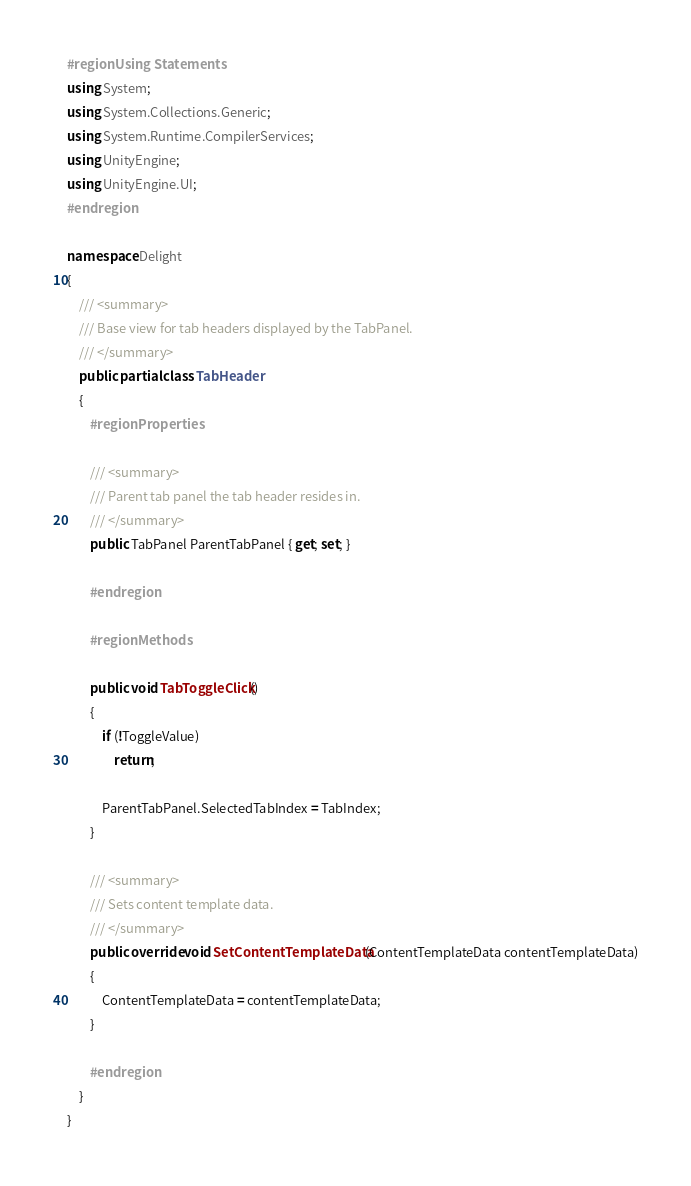<code> <loc_0><loc_0><loc_500><loc_500><_C#_>#region Using Statements
using System;
using System.Collections.Generic;
using System.Runtime.CompilerServices;
using UnityEngine;
using UnityEngine.UI;
#endregion

namespace Delight
{
    /// <summary>
    /// Base view for tab headers displayed by the TabPanel.
    /// </summary>
    public partial class TabHeader
    {
        #region Properties

        /// <summary>
        /// Parent tab panel the tab header resides in.
        /// </summary>
        public TabPanel ParentTabPanel { get; set; }

        #endregion

        #region Methods

        public void TabToggleClick()
        {
            if (!ToggleValue)
                return;

            ParentTabPanel.SelectedTabIndex = TabIndex;
        }

        /// <summary>
        /// Sets content template data.
        /// </summary>
        public override void SetContentTemplateData(ContentTemplateData contentTemplateData)
        {
            ContentTemplateData = contentTemplateData;
        }

        #endregion
    }
}
</code> 